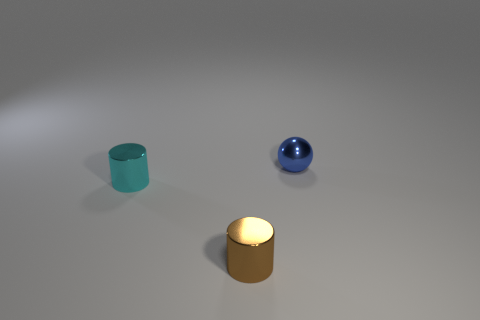Add 3 small metal objects. How many objects exist? 6 Subtract all spheres. How many objects are left? 2 Subtract 0 yellow cylinders. How many objects are left? 3 Subtract all tiny cyan rubber objects. Subtract all tiny cylinders. How many objects are left? 1 Add 1 cylinders. How many cylinders are left? 3 Add 1 blue matte cylinders. How many blue matte cylinders exist? 1 